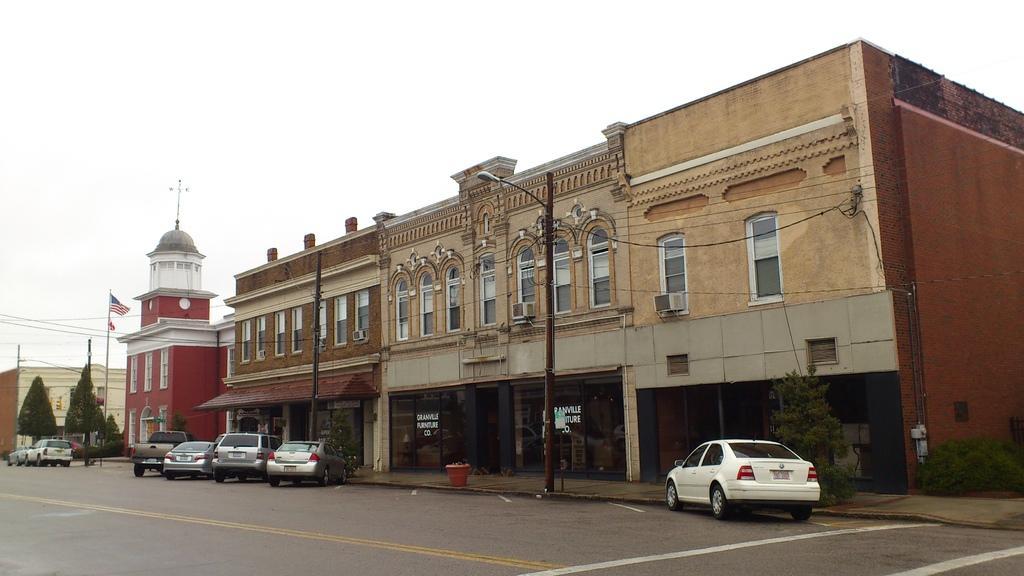In one or two sentences, can you explain what this image depicts? In this picture there is a building. In front of the building we can see many cars, street lights and electric pole. On the right we can see plants. On the left we can see trees and flag. Here we can see dome. On the top there is a sky. Here we can see electric pole and wires are connected to it. On the bottom there is a road. 